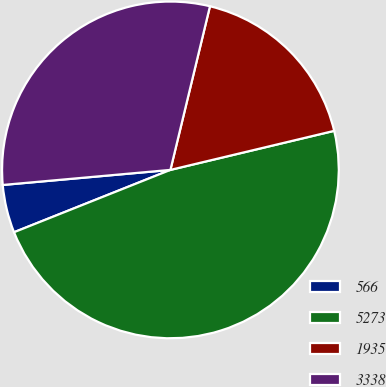<chart> <loc_0><loc_0><loc_500><loc_500><pie_chart><fcel>566<fcel>5273<fcel>1935<fcel>3338<nl><fcel>4.61%<fcel>47.69%<fcel>17.5%<fcel>30.2%<nl></chart> 